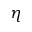<formula> <loc_0><loc_0><loc_500><loc_500>\eta</formula> 